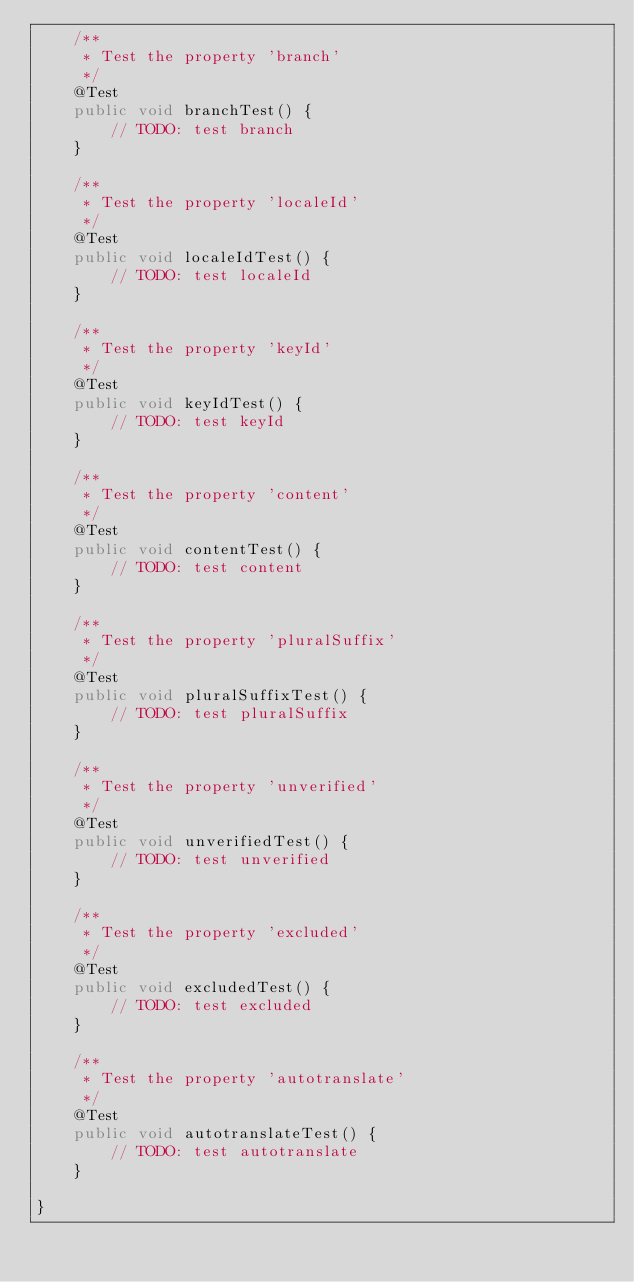Convert code to text. <code><loc_0><loc_0><loc_500><loc_500><_Java_>    /**
     * Test the property 'branch'
     */
    @Test
    public void branchTest() {
        // TODO: test branch
    }

    /**
     * Test the property 'localeId'
     */
    @Test
    public void localeIdTest() {
        // TODO: test localeId
    }

    /**
     * Test the property 'keyId'
     */
    @Test
    public void keyIdTest() {
        // TODO: test keyId
    }

    /**
     * Test the property 'content'
     */
    @Test
    public void contentTest() {
        // TODO: test content
    }

    /**
     * Test the property 'pluralSuffix'
     */
    @Test
    public void pluralSuffixTest() {
        // TODO: test pluralSuffix
    }

    /**
     * Test the property 'unverified'
     */
    @Test
    public void unverifiedTest() {
        // TODO: test unverified
    }

    /**
     * Test the property 'excluded'
     */
    @Test
    public void excludedTest() {
        // TODO: test excluded
    }

    /**
     * Test the property 'autotranslate'
     */
    @Test
    public void autotranslateTest() {
        // TODO: test autotranslate
    }

}
</code> 